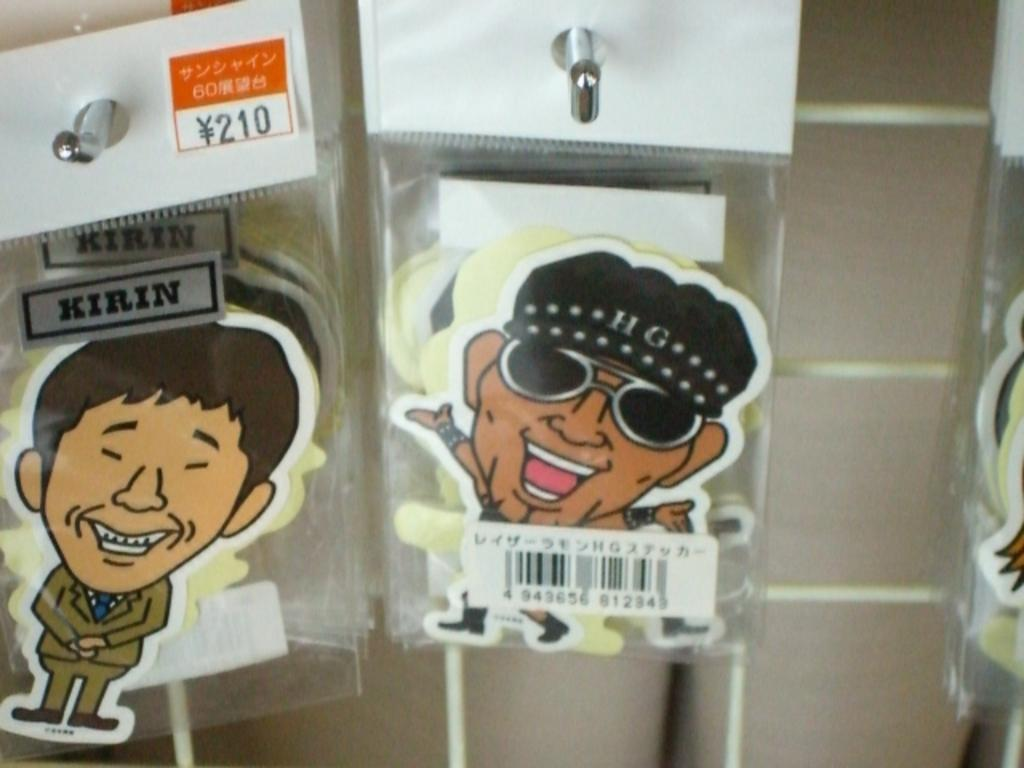What objects are in the image that have stickers on them? There are packets with stickers in the image. How are the packets with stickers positioned in the image? The packets are attached to a wall hook. What can be seen in the background of the image? There is a wall visible in the background of the image. What type of animal can be seen drinking from a cup in the image? There is no animal or cup present in the image; it only features packets with stickers attached to a wall hook. 